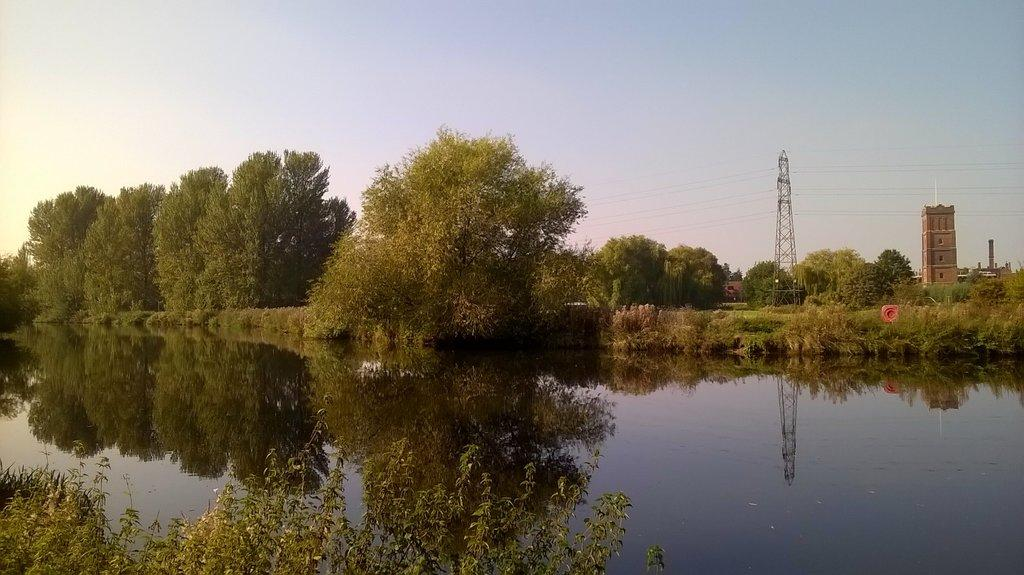What is located in the front of the image? There are leaves in the front of the image. What is in the center of the image? There is water in the center of the image. What can be seen in the background of the image? There are trees and towers in the background of the image. What type of circle is visible in the image? There is no circle present in the image. What team is responsible for maintaining the towers in the background? There is no team mentioned or implied in the image, and the towers' maintenance is not relevant to the image's content. 